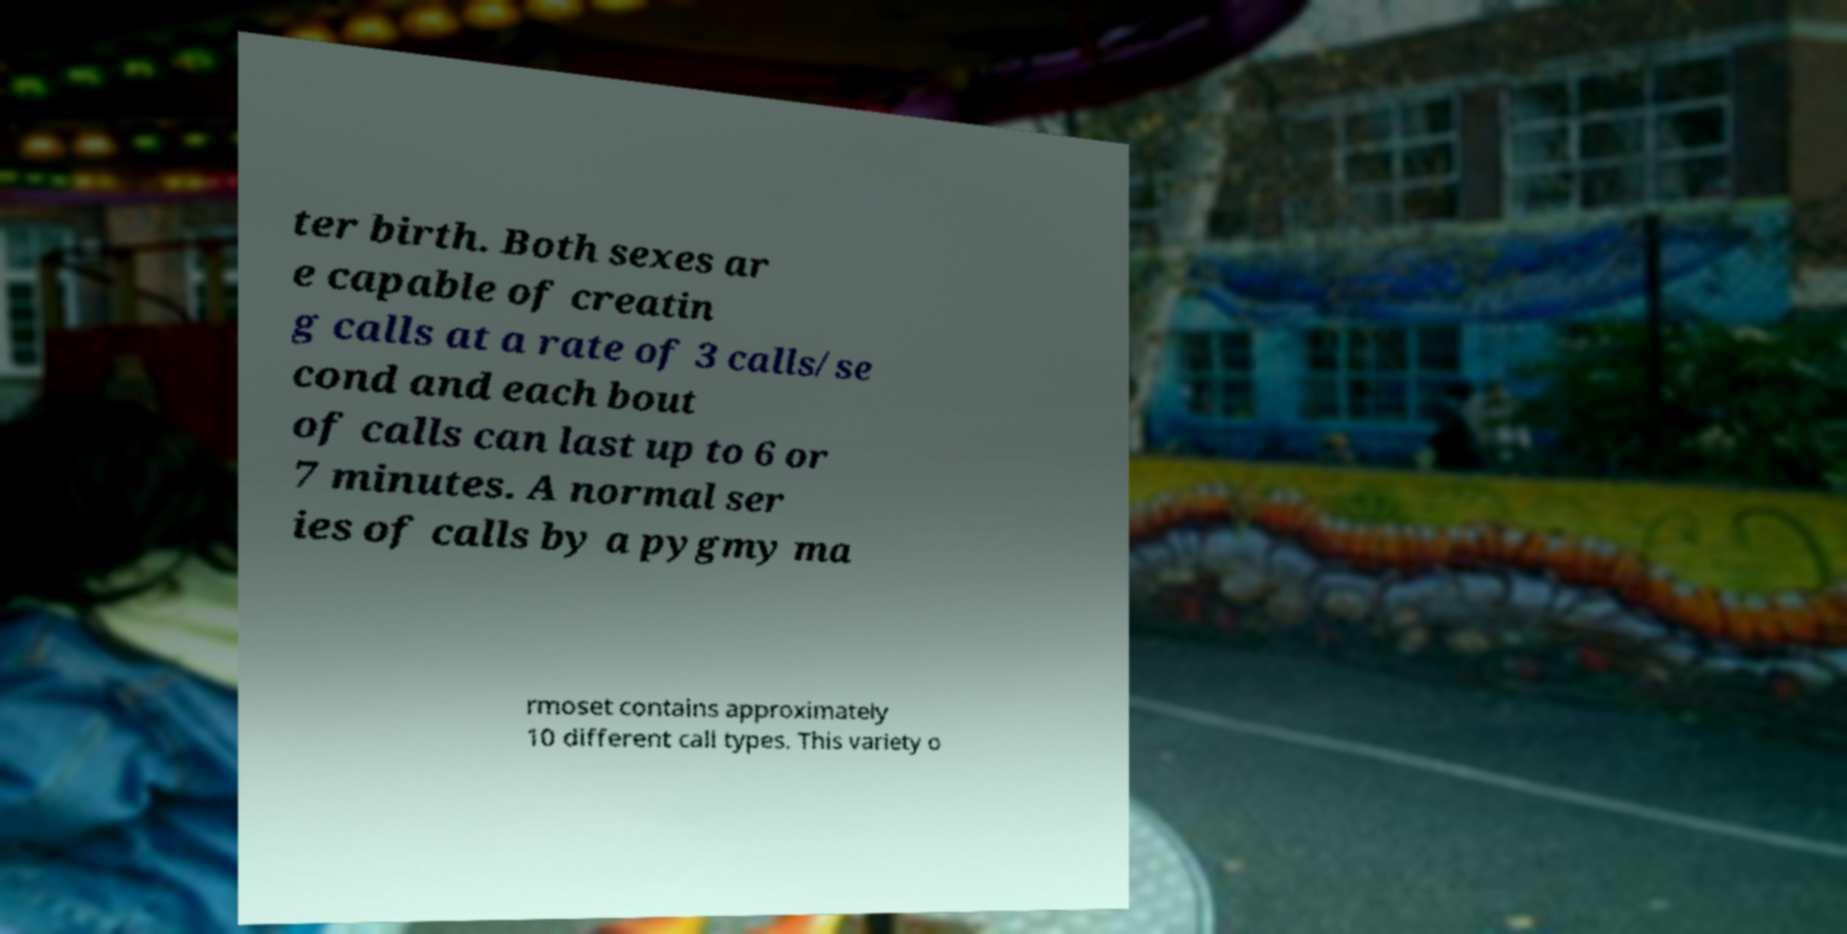I need the written content from this picture converted into text. Can you do that? ter birth. Both sexes ar e capable of creatin g calls at a rate of 3 calls/se cond and each bout of calls can last up to 6 or 7 minutes. A normal ser ies of calls by a pygmy ma rmoset contains approximately 10 different call types. This variety o 